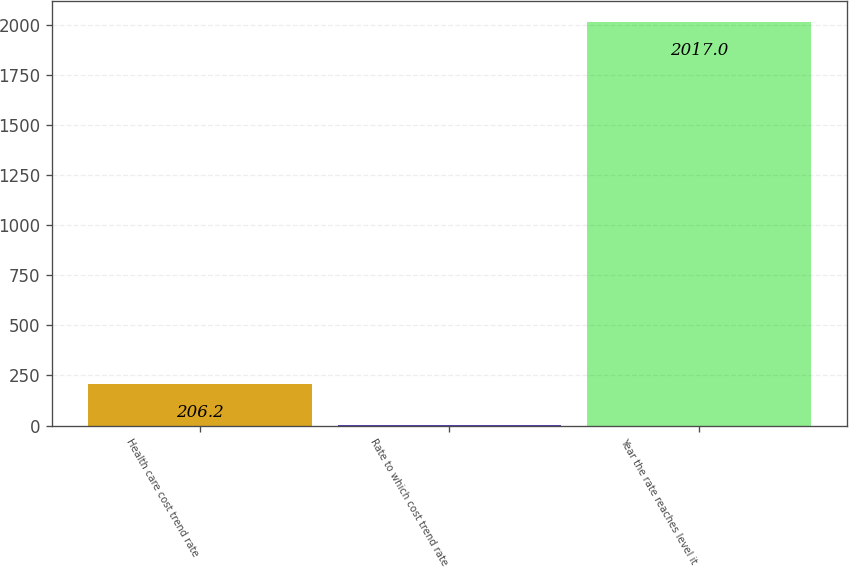<chart> <loc_0><loc_0><loc_500><loc_500><bar_chart><fcel>Health care cost trend rate<fcel>Rate to which cost trend rate<fcel>Year the rate reaches level it<nl><fcel>206.2<fcel>5<fcel>2017<nl></chart> 